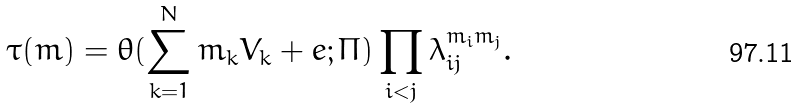<formula> <loc_0><loc_0><loc_500><loc_500>\tau ( m ) = \theta ( \sum _ { k = 1 } ^ { N } m _ { k } V _ { k } + e ; \Pi ) \prod _ { i < j } \lambda _ { i j } ^ { m _ { i } m _ { j } } .</formula> 